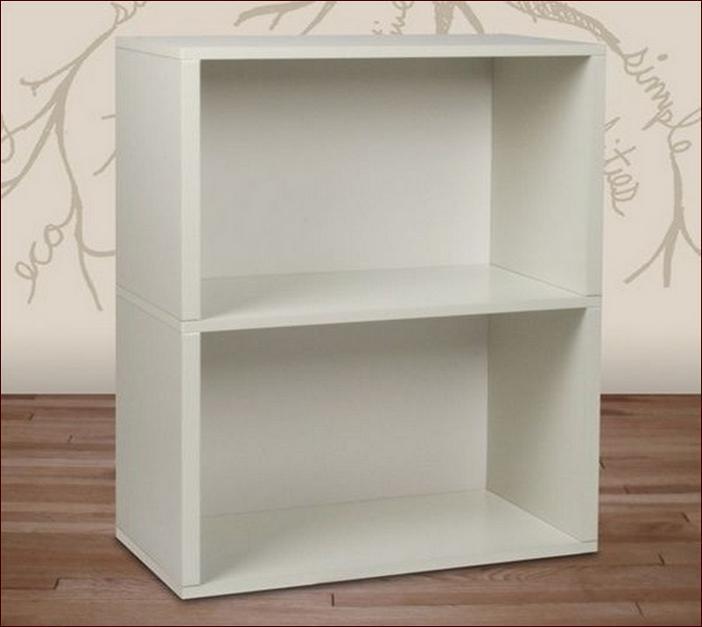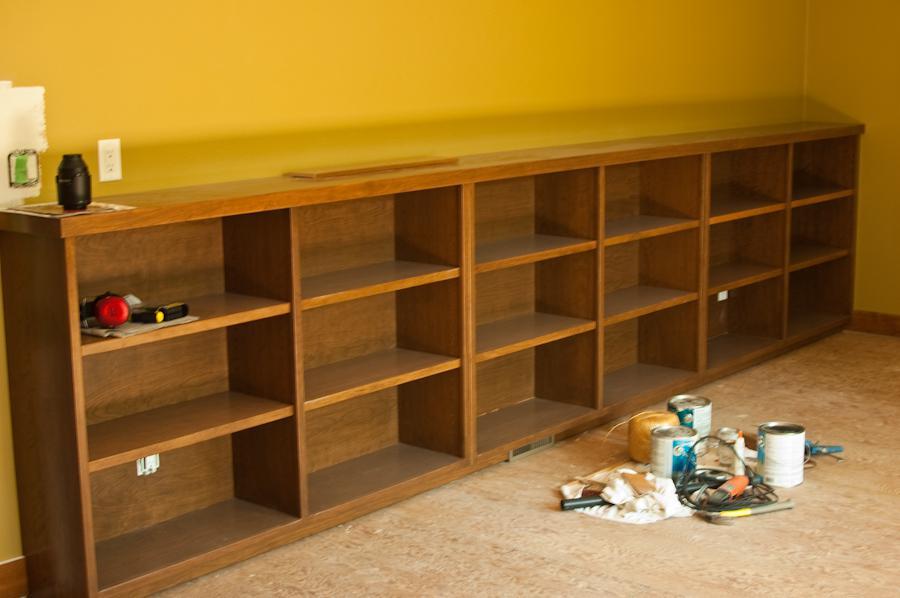The first image is the image on the left, the second image is the image on the right. Evaluate the accuracy of this statement regarding the images: "There is something on the top and inside of a horizontal bookshelf unit, in one image.". Is it true? Answer yes or no. Yes. The first image is the image on the left, the second image is the image on the right. For the images shown, is this caption "One shelving unit is narrow with only two inner levels, while a second shelving unit is much wider with three inner levels of shelves." true? Answer yes or no. Yes. 